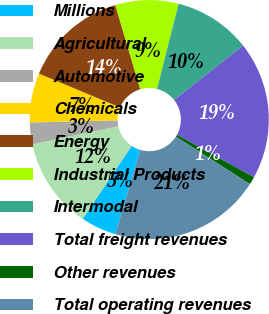Convert chart to OTSL. <chart><loc_0><loc_0><loc_500><loc_500><pie_chart><fcel>Millions<fcel>Agricultural<fcel>Automotive<fcel>Chemicals<fcel>Energy<fcel>Industrial Products<fcel>Intermodal<fcel>Total freight revenues<fcel>Other revenues<fcel>Total operating revenues<nl><fcel>4.81%<fcel>12.27%<fcel>2.94%<fcel>6.67%<fcel>14.13%<fcel>8.54%<fcel>10.4%<fcel>18.65%<fcel>1.07%<fcel>20.52%<nl></chart> 